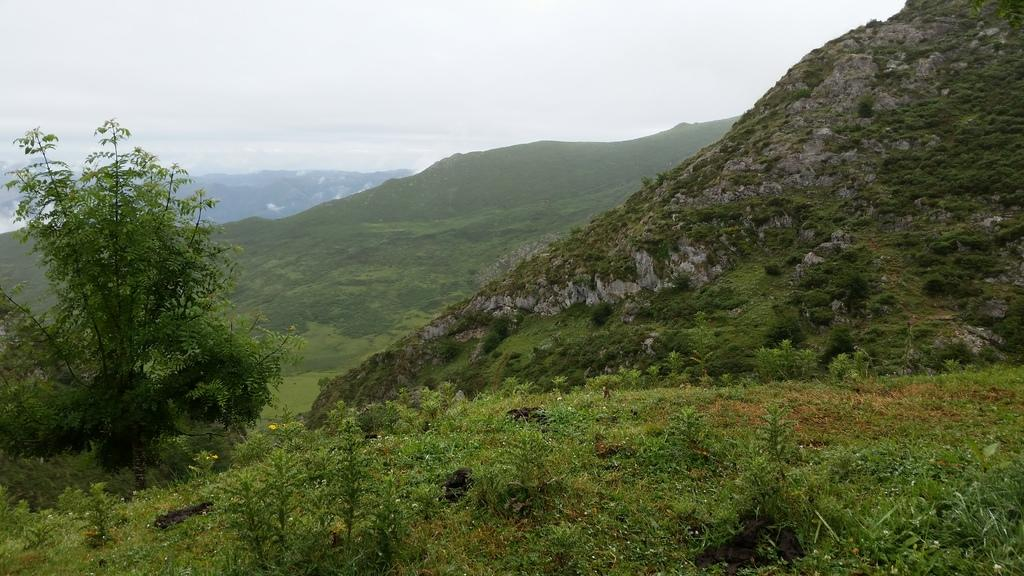What type of vegetation can be seen in the image? There are plants and trees in the image. What can be seen in the background of the image? Hills and the sky are visible in the background of the image. What type of boat is visible in the image? There is no boat present in the image. What event is taking place in the image? There is no specific event depicted in the image; it simply shows plants, trees, hills, and the sky. 